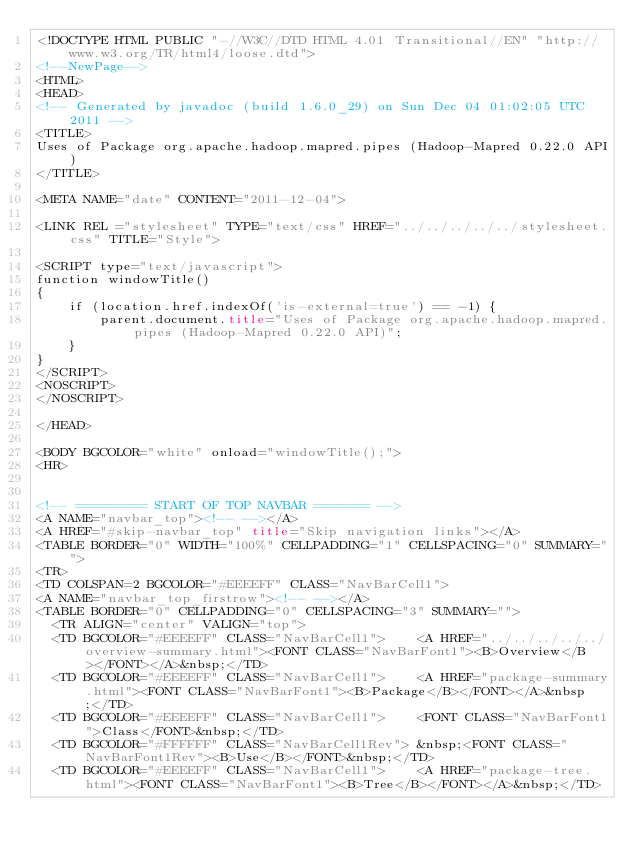Convert code to text. <code><loc_0><loc_0><loc_500><loc_500><_HTML_><!DOCTYPE HTML PUBLIC "-//W3C//DTD HTML 4.01 Transitional//EN" "http://www.w3.org/TR/html4/loose.dtd">
<!--NewPage-->
<HTML>
<HEAD>
<!-- Generated by javadoc (build 1.6.0_29) on Sun Dec 04 01:02:05 UTC 2011 -->
<TITLE>
Uses of Package org.apache.hadoop.mapred.pipes (Hadoop-Mapred 0.22.0 API)
</TITLE>

<META NAME="date" CONTENT="2011-12-04">

<LINK REL ="stylesheet" TYPE="text/css" HREF="../../../../../stylesheet.css" TITLE="Style">

<SCRIPT type="text/javascript">
function windowTitle()
{
    if (location.href.indexOf('is-external=true') == -1) {
        parent.document.title="Uses of Package org.apache.hadoop.mapred.pipes (Hadoop-Mapred 0.22.0 API)";
    }
}
</SCRIPT>
<NOSCRIPT>
</NOSCRIPT>

</HEAD>

<BODY BGCOLOR="white" onload="windowTitle();">
<HR>


<!-- ========= START OF TOP NAVBAR ======= -->
<A NAME="navbar_top"><!-- --></A>
<A HREF="#skip-navbar_top" title="Skip navigation links"></A>
<TABLE BORDER="0" WIDTH="100%" CELLPADDING="1" CELLSPACING="0" SUMMARY="">
<TR>
<TD COLSPAN=2 BGCOLOR="#EEEEFF" CLASS="NavBarCell1">
<A NAME="navbar_top_firstrow"><!-- --></A>
<TABLE BORDER="0" CELLPADDING="0" CELLSPACING="3" SUMMARY="">
  <TR ALIGN="center" VALIGN="top">
  <TD BGCOLOR="#EEEEFF" CLASS="NavBarCell1">    <A HREF="../../../../../overview-summary.html"><FONT CLASS="NavBarFont1"><B>Overview</B></FONT></A>&nbsp;</TD>
  <TD BGCOLOR="#EEEEFF" CLASS="NavBarCell1">    <A HREF="package-summary.html"><FONT CLASS="NavBarFont1"><B>Package</B></FONT></A>&nbsp;</TD>
  <TD BGCOLOR="#EEEEFF" CLASS="NavBarCell1">    <FONT CLASS="NavBarFont1">Class</FONT>&nbsp;</TD>
  <TD BGCOLOR="#FFFFFF" CLASS="NavBarCell1Rev"> &nbsp;<FONT CLASS="NavBarFont1Rev"><B>Use</B></FONT>&nbsp;</TD>
  <TD BGCOLOR="#EEEEFF" CLASS="NavBarCell1">    <A HREF="package-tree.html"><FONT CLASS="NavBarFont1"><B>Tree</B></FONT></A>&nbsp;</TD></code> 